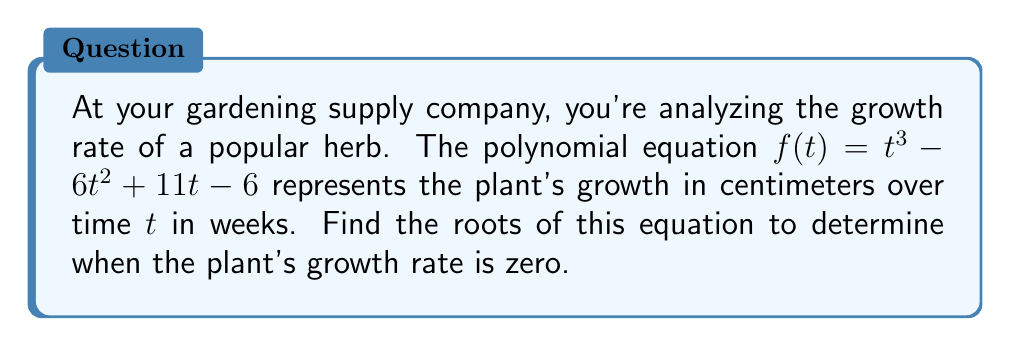Provide a solution to this math problem. To find the roots of the polynomial equation $f(t) = t^3 - 6t^2 + 11t - 6$, we need to factor it:

1) First, let's check if there are any rational roots using the rational root theorem. The possible rational roots are the factors of the constant term: ±1, ±2, ±3, ±6.

2) Testing these values, we find that t = 1 is a root.

3) We can factor out (t - 1):
   $t^3 - 6t^2 + 11t - 6 = (t - 1)(t^2 - 5t + 6)$

4) Now we need to factor the quadratic term $t^2 - 5t + 6$:
   $t^2 - 5t + 6 = (t - 2)(t - 3)$

5) Therefore, the fully factored equation is:
   $f(t) = (t - 1)(t - 2)(t - 3)$

6) The roots of the equation are the values that make each factor equal to zero:
   $t - 1 = 0$, $t - 2 = 0$, $t - 3 = 0$

7) Solving these, we get the roots: t = 1, t = 2, and t = 3.
Answer: t = 1, 2, 3 